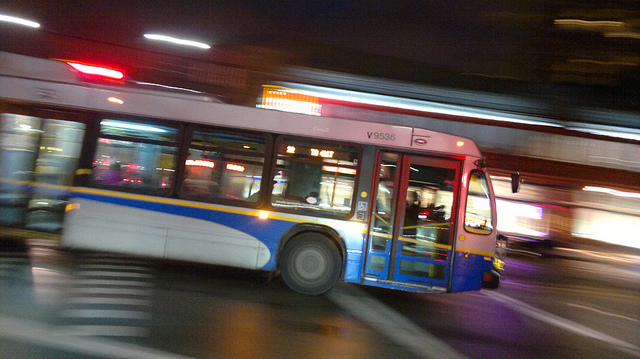Please transcribe the text information in this image. V9536 